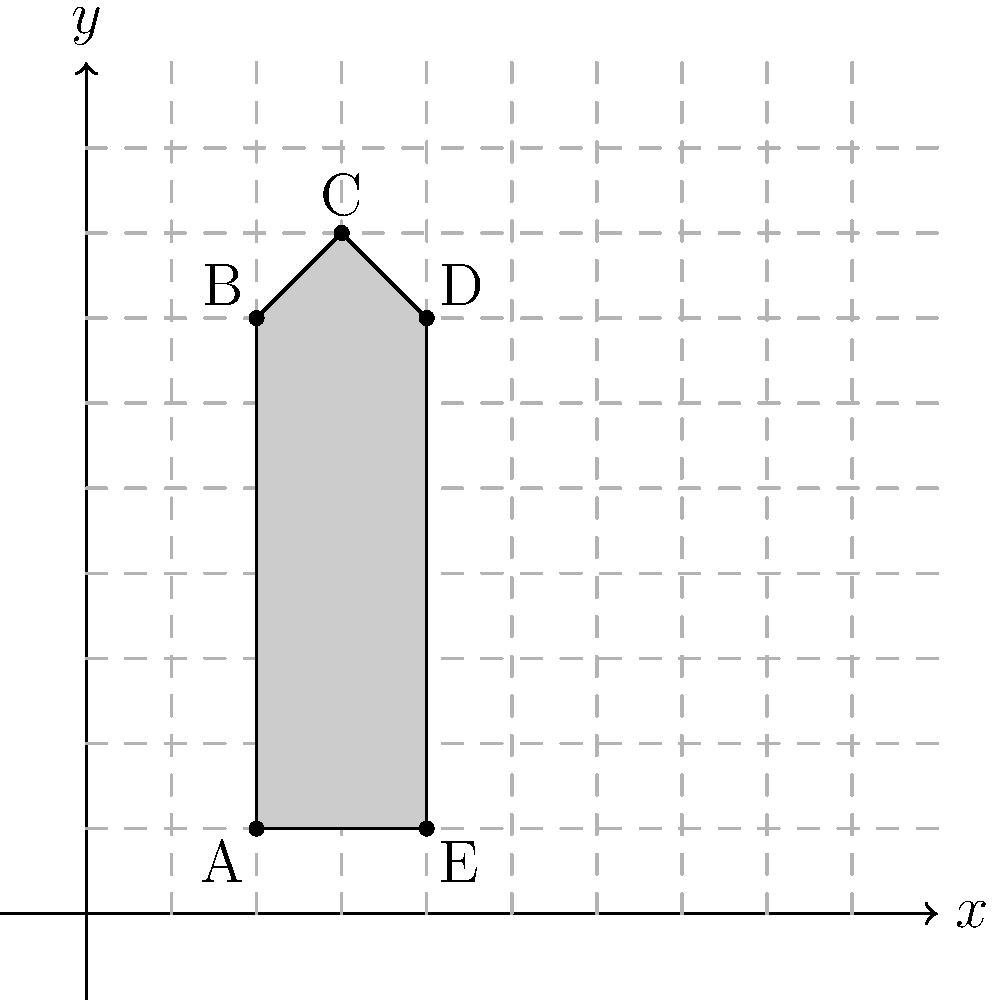In your kitchen, you've decided to sketch a simplified shape of a whisk on graph paper to record its dimensions. The shape is represented on a coordinate plane as shown in the figure. What is the area of this whisk shape in square units? To find the area of the whisk shape, we can break it down into simpler geometric shapes:

1. The main body of the whisk is a rectangle:
   Width = 4 - 2 = 2 units
   Height = 7 - 1 = 6 units
   Area of rectangle = 2 × 6 = 12 square units

2. The top of the whisk is a triangle:
   Base = 2 units (same as the rectangle's width)
   Height = 8 - 7 = 1 unit
   Area of triangle = $\frac{1}{2}$ × 2 × 1 = 1 square unit

3. Total area:
   Area of whisk = Area of rectangle + Area of triangle
                 = 12 + 1 = 13 square units

Therefore, the area of the whisk shape is 13 square units.
Answer: 13 square units 